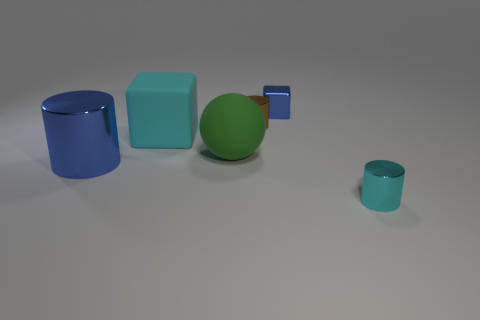What material is the cylinder that is the same color as the big cube?
Ensure brevity in your answer.  Metal. There is a metallic thing that is behind the big blue cylinder and in front of the blue metal block; what is its size?
Your answer should be very brief. Small. How many other objects are the same color as the ball?
Offer a very short reply. 0. There is a metallic object that is on the left side of the tiny metal cylinder behind the object in front of the blue metal cylinder; how big is it?
Your response must be concise. Large. There is a cyan matte block; are there any small blue things to the left of it?
Make the answer very short. No. Is the size of the brown object the same as the cyan thing to the left of the cyan metallic cylinder?
Your response must be concise. No. What number of other objects are there of the same material as the tiny brown cylinder?
Your answer should be very brief. 3. There is a thing that is both in front of the brown shiny cylinder and to the right of the big green ball; what shape is it?
Ensure brevity in your answer.  Cylinder. Is the size of the blue block that is left of the cyan shiny cylinder the same as the blue shiny thing that is on the left side of the big cyan matte object?
Offer a terse response. No. There is a cyan thing that is the same material as the small brown cylinder; what shape is it?
Provide a succinct answer. Cylinder. 